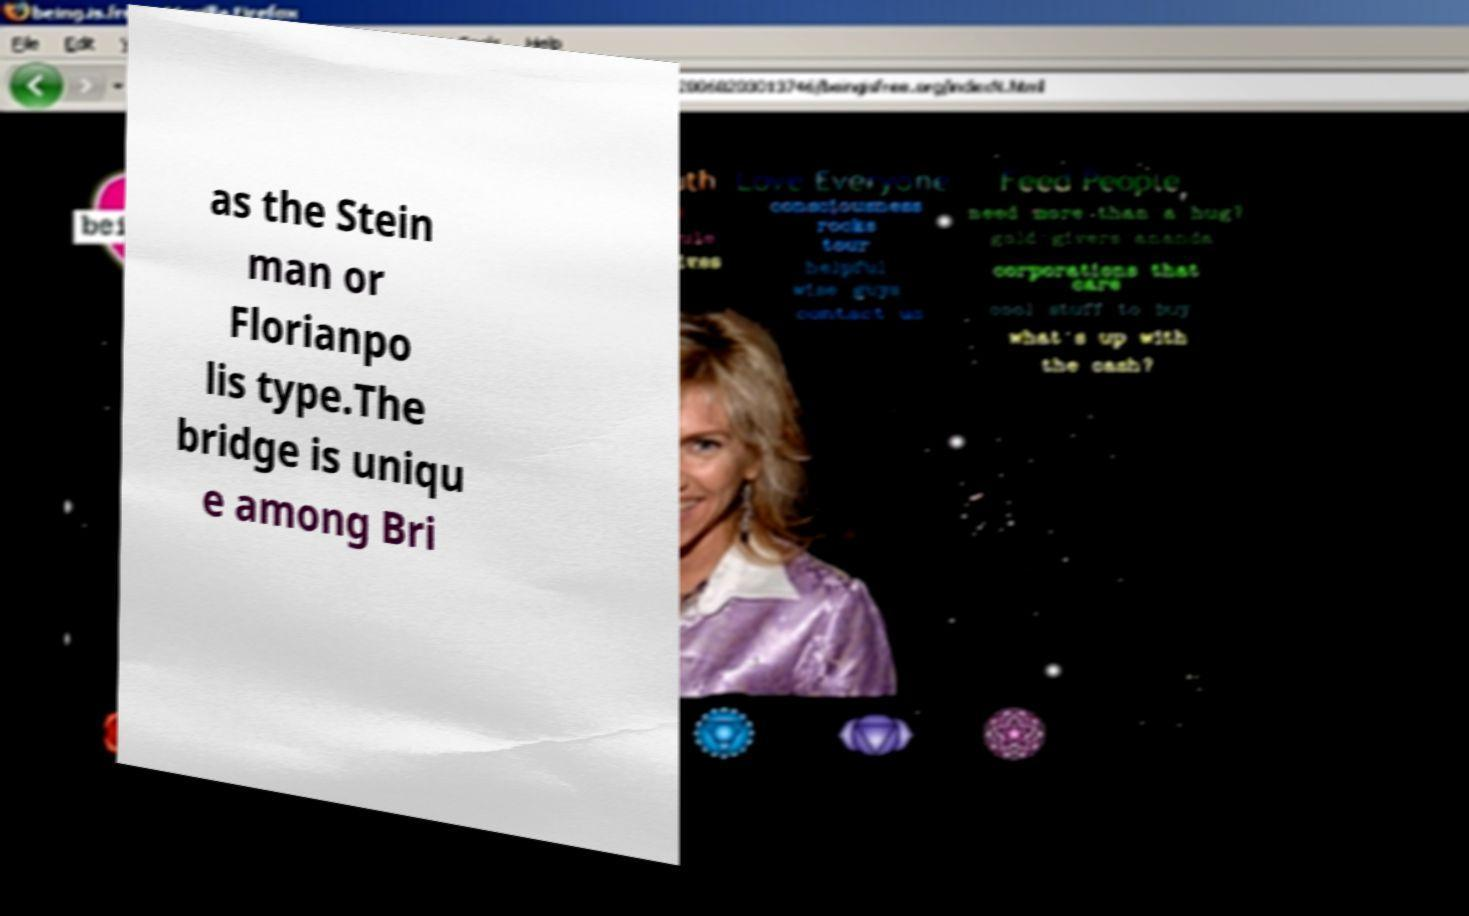Please read and relay the text visible in this image. What does it say? as the Stein man or Florianpo lis type.The bridge is uniqu e among Bri 